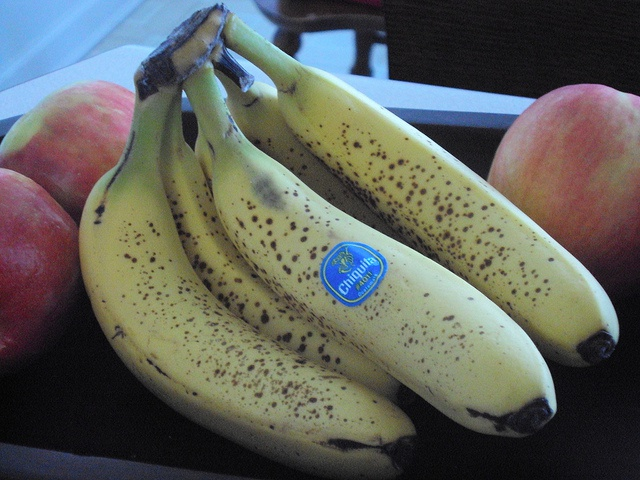Describe the objects in this image and their specific colors. I can see banana in lightblue, olive, gray, black, and darkgray tones, apple in lightblue, brown, darkgray, and black tones, apple in lightblue, maroon, black, and purple tones, and apple in lightblue, brown, darkgray, and purple tones in this image. 